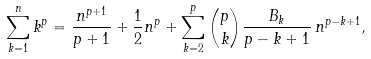Convert formula to latex. <formula><loc_0><loc_0><loc_500><loc_500>\sum _ { k = 1 } ^ { n } k ^ { p } = { \frac { n ^ { p + 1 } } { p + 1 } } + { \frac { 1 } { 2 } } n ^ { p } + \sum _ { k = 2 } ^ { p } { \binom { p } { k } } { \frac { B _ { k } } { p - k + 1 } } \, n ^ { p - k + 1 } ,</formula> 